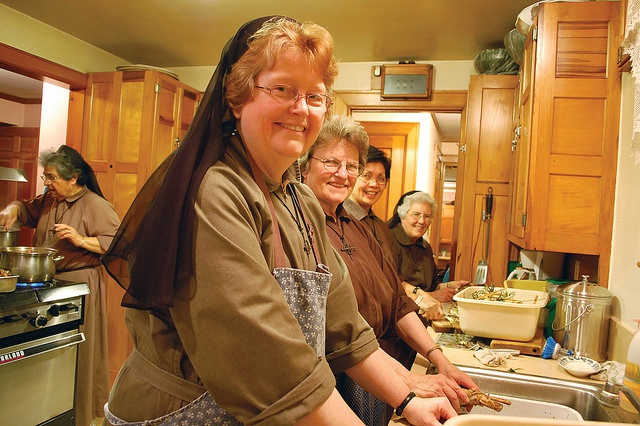Describe the objects in this image and their specific colors. I can see people in olive, maroon, black, and brown tones, people in olive, brown, maroon, tan, and black tones, people in olive, maroon, brown, and black tones, oven in olive and black tones, and sink in olive and tan tones in this image. 